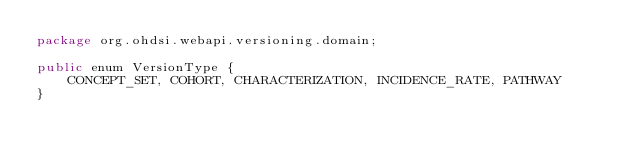Convert code to text. <code><loc_0><loc_0><loc_500><loc_500><_Java_>package org.ohdsi.webapi.versioning.domain;

public enum VersionType {
    CONCEPT_SET, COHORT, CHARACTERIZATION, INCIDENCE_RATE, PATHWAY
}
</code> 